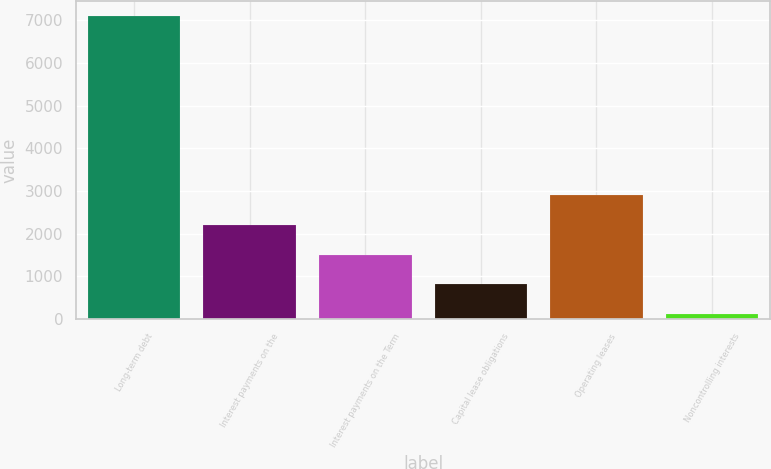Convert chart to OTSL. <chart><loc_0><loc_0><loc_500><loc_500><bar_chart><fcel>Long-term debt<fcel>Interest payments on the<fcel>Interest payments on the Term<fcel>Capital lease obligations<fcel>Operating leases<fcel>Noncontrolling interests<nl><fcel>7092<fcel>2203.9<fcel>1505.6<fcel>807.3<fcel>2902.2<fcel>109<nl></chart> 